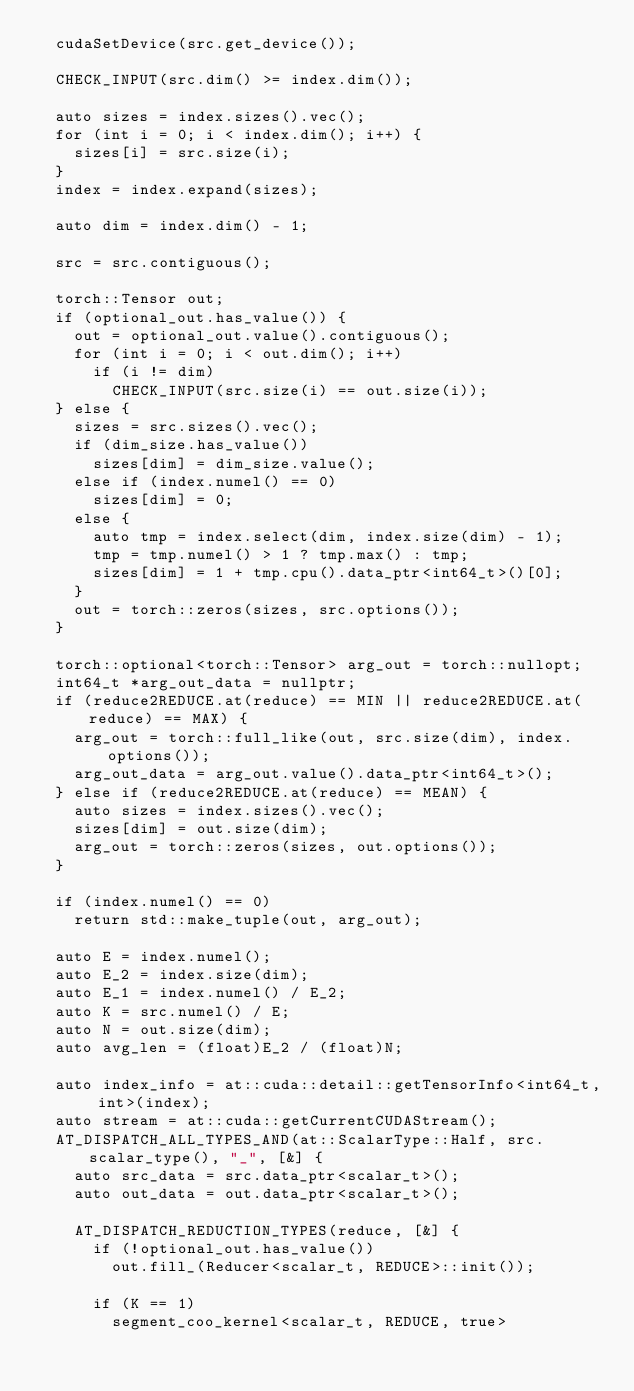Convert code to text. <code><loc_0><loc_0><loc_500><loc_500><_Cuda_>  cudaSetDevice(src.get_device());

  CHECK_INPUT(src.dim() >= index.dim());

  auto sizes = index.sizes().vec();
  for (int i = 0; i < index.dim(); i++) {
    sizes[i] = src.size(i);
  }
  index = index.expand(sizes);

  auto dim = index.dim() - 1;

  src = src.contiguous();

  torch::Tensor out;
  if (optional_out.has_value()) {
    out = optional_out.value().contiguous();
    for (int i = 0; i < out.dim(); i++)
      if (i != dim)
        CHECK_INPUT(src.size(i) == out.size(i));
  } else {
    sizes = src.sizes().vec();
    if (dim_size.has_value())
      sizes[dim] = dim_size.value();
    else if (index.numel() == 0)
      sizes[dim] = 0;
    else {
      auto tmp = index.select(dim, index.size(dim) - 1);
      tmp = tmp.numel() > 1 ? tmp.max() : tmp;
      sizes[dim] = 1 + tmp.cpu().data_ptr<int64_t>()[0];
    }
    out = torch::zeros(sizes, src.options());
  }

  torch::optional<torch::Tensor> arg_out = torch::nullopt;
  int64_t *arg_out_data = nullptr;
  if (reduce2REDUCE.at(reduce) == MIN || reduce2REDUCE.at(reduce) == MAX) {
    arg_out = torch::full_like(out, src.size(dim), index.options());
    arg_out_data = arg_out.value().data_ptr<int64_t>();
  } else if (reduce2REDUCE.at(reduce) == MEAN) {
    auto sizes = index.sizes().vec();
    sizes[dim] = out.size(dim);
    arg_out = torch::zeros(sizes, out.options());
  }

  if (index.numel() == 0)
    return std::make_tuple(out, arg_out);

  auto E = index.numel();
  auto E_2 = index.size(dim);
  auto E_1 = index.numel() / E_2;
  auto K = src.numel() / E;
  auto N = out.size(dim);
  auto avg_len = (float)E_2 / (float)N;

  auto index_info = at::cuda::detail::getTensorInfo<int64_t, int>(index);
  auto stream = at::cuda::getCurrentCUDAStream();
  AT_DISPATCH_ALL_TYPES_AND(at::ScalarType::Half, src.scalar_type(), "_", [&] {
    auto src_data = src.data_ptr<scalar_t>();
    auto out_data = out.data_ptr<scalar_t>();

    AT_DISPATCH_REDUCTION_TYPES(reduce, [&] {
      if (!optional_out.has_value())
        out.fill_(Reducer<scalar_t, REDUCE>::init());

      if (K == 1)
        segment_coo_kernel<scalar_t, REDUCE, true></code> 